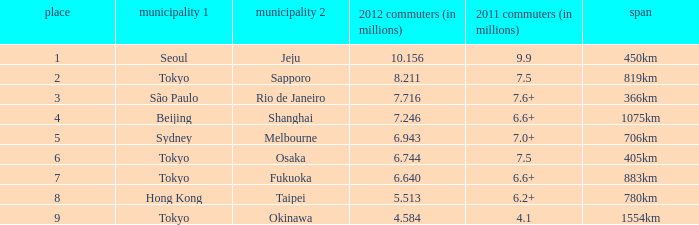How many passengers (in millions) flew through along the route that is 1075km long in 2012? 7.246. 